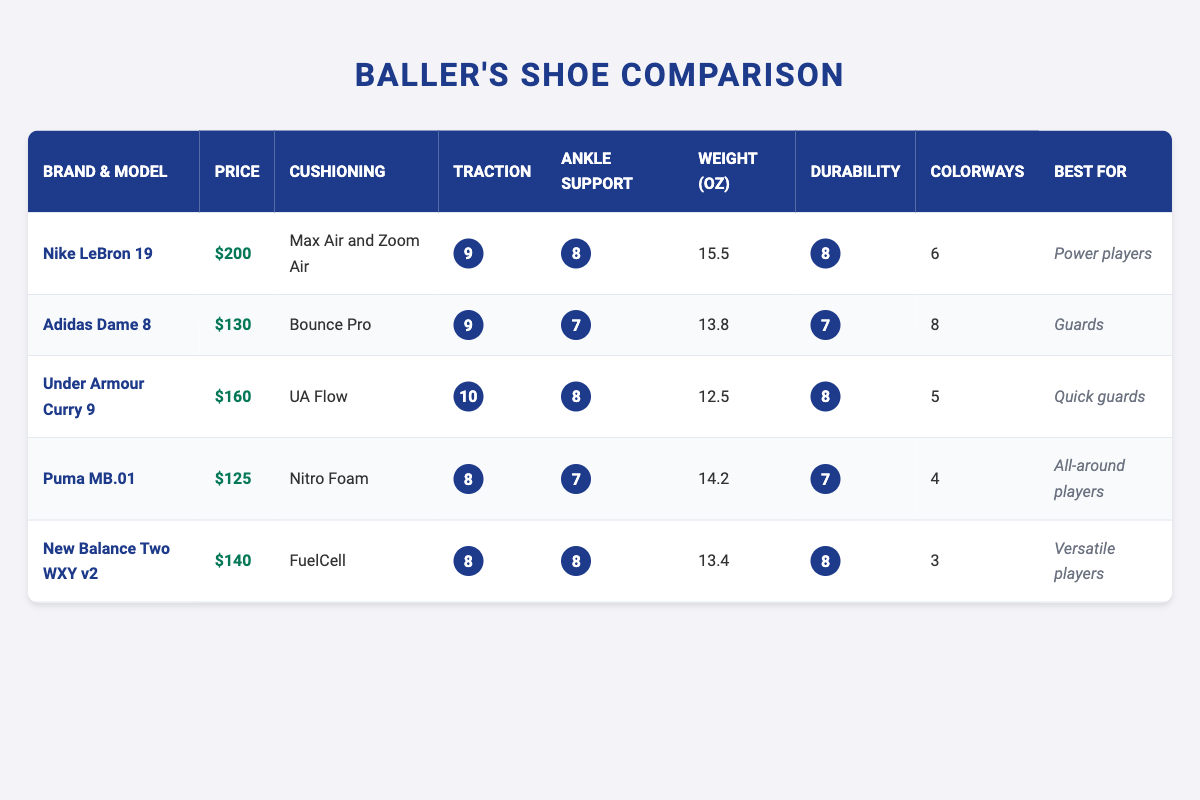What is the most expensive shoe in the table? The most expensive shoe can be found by comparing the price column. The Nike LeBron 19 has a price of $200, which is higher than all other prices listed for the other brands.
Answer: Nike LeBron 19 Which shoe has the best traction score? The traction scores are given as ratings from 1 to 10. Checking the ratings, the Under Armour Curry 9 has a traction score of 10, which is the highest in the table.
Answer: Under Armour Curry 9 What are the colorways available for Puma MB.01? The Puma MB.01 has a total of 4 colorways available. This can be found directly in the corresponding column for the Puma model listed in the table.
Answer: 4 Is the Adidas Dame 8 cheaper than New Balance Two WXY v2? To find out if the Adidas Dame 8 is cheaper, I look at their prices: Adidas Dame 8 is $130 and New Balance Two WXY v2 is $140. Since $130 is less than $140, the statement is true.
Answer: Yes What is the average weight of the shoes listed in the table? To find the average weight, sum the weights of all the shoes: 15.5 + 13.8 + 12.5 + 14.2 + 13.4 = 69.4 ounces. There are 5 shoes, so the average weight is 69.4 / 5 = 13.88 ounces.
Answer: 13.88 ounces Which shoe is best for power players based on the table? To answer this, I check the "Best For" column to see which shoe is labeled for power players. The Nike LeBron 19 is specifically listed as the best for power players.
Answer: Nike LeBron 19 How many shoes weigh less than 15 ounces? I look at the weight column and identify the shoes that weigh less than 15 ounces. The Under Armour Curry 9 (12.5 oz) and Adidas Dame 8 (13.8 oz) fit this criterion, making a total of 2 shoes.
Answer: 2 Does the Puma MB.01 have better durability than the New Balance Two WXY v2? To find out if the Puma MB.01 has better durability, I compare their durability ratings. Puma MB.01 has a rating of 7, while New Balance Two WXY v2 has a rating of 8. Since 7 is less than 8, Puma MB.01 does not have better durability.
Answer: No 